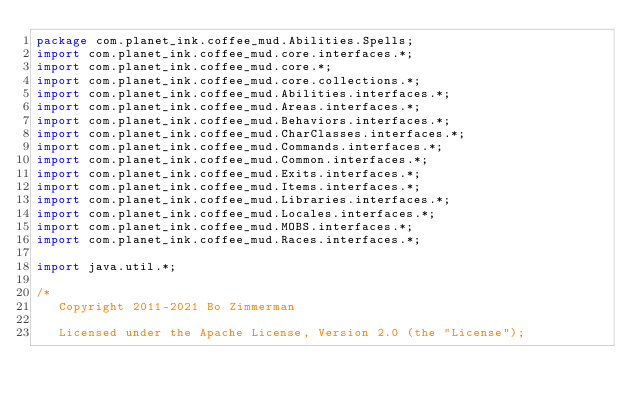Convert code to text. <code><loc_0><loc_0><loc_500><loc_500><_Java_>package com.planet_ink.coffee_mud.Abilities.Spells;
import com.planet_ink.coffee_mud.core.interfaces.*;
import com.planet_ink.coffee_mud.core.*;
import com.planet_ink.coffee_mud.core.collections.*;
import com.planet_ink.coffee_mud.Abilities.interfaces.*;
import com.planet_ink.coffee_mud.Areas.interfaces.*;
import com.planet_ink.coffee_mud.Behaviors.interfaces.*;
import com.planet_ink.coffee_mud.CharClasses.interfaces.*;
import com.planet_ink.coffee_mud.Commands.interfaces.*;
import com.planet_ink.coffee_mud.Common.interfaces.*;
import com.planet_ink.coffee_mud.Exits.interfaces.*;
import com.planet_ink.coffee_mud.Items.interfaces.*;
import com.planet_ink.coffee_mud.Libraries.interfaces.*;
import com.planet_ink.coffee_mud.Locales.interfaces.*;
import com.planet_ink.coffee_mud.MOBS.interfaces.*;
import com.planet_ink.coffee_mud.Races.interfaces.*;

import java.util.*;

/*
   Copyright 2011-2021 Bo Zimmerman

   Licensed under the Apache License, Version 2.0 (the "License");</code> 